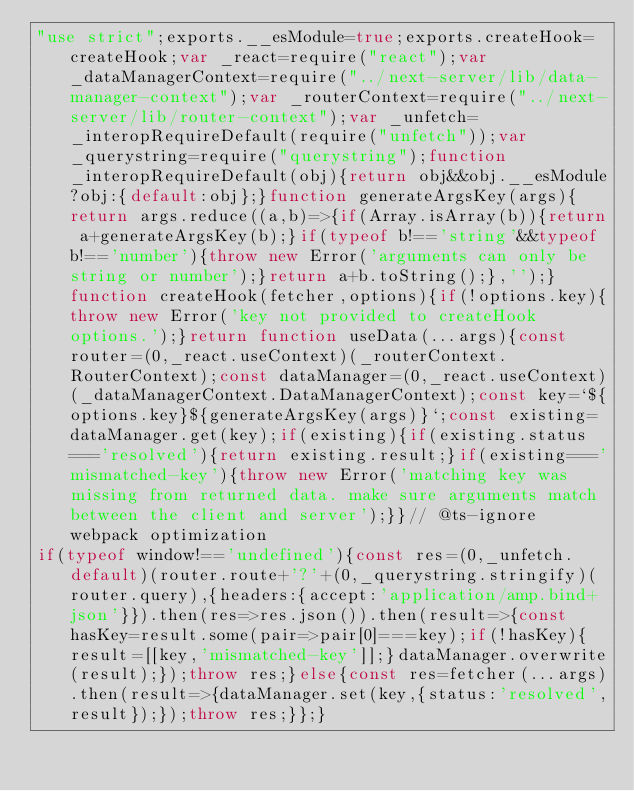Convert code to text. <code><loc_0><loc_0><loc_500><loc_500><_JavaScript_>"use strict";exports.__esModule=true;exports.createHook=createHook;var _react=require("react");var _dataManagerContext=require("../next-server/lib/data-manager-context");var _routerContext=require("../next-server/lib/router-context");var _unfetch=_interopRequireDefault(require("unfetch"));var _querystring=require("querystring");function _interopRequireDefault(obj){return obj&&obj.__esModule?obj:{default:obj};}function generateArgsKey(args){return args.reduce((a,b)=>{if(Array.isArray(b)){return a+generateArgsKey(b);}if(typeof b!=='string'&&typeof b!=='number'){throw new Error('arguments can only be string or number');}return a+b.toString();},'');}function createHook(fetcher,options){if(!options.key){throw new Error('key not provided to createHook options.');}return function useData(...args){const router=(0,_react.useContext)(_routerContext.RouterContext);const dataManager=(0,_react.useContext)(_dataManagerContext.DataManagerContext);const key=`${options.key}${generateArgsKey(args)}`;const existing=dataManager.get(key);if(existing){if(existing.status==='resolved'){return existing.result;}if(existing==='mismatched-key'){throw new Error('matching key was missing from returned data. make sure arguments match between the client and server');}}// @ts-ignore webpack optimization
if(typeof window!=='undefined'){const res=(0,_unfetch.default)(router.route+'?'+(0,_querystring.stringify)(router.query),{headers:{accept:'application/amp.bind+json'}}).then(res=>res.json()).then(result=>{const hasKey=result.some(pair=>pair[0]===key);if(!hasKey){result=[[key,'mismatched-key']];}dataManager.overwrite(result);});throw res;}else{const res=fetcher(...args).then(result=>{dataManager.set(key,{status:'resolved',result});});throw res;}};}</code> 